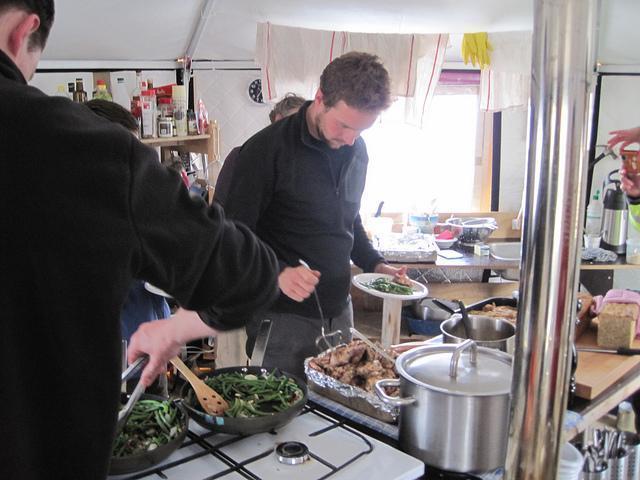How many yellow rubber gloves are in the picture?
Give a very brief answer. 2. How many people are in the picture?
Give a very brief answer. 2. How many ovens are in the picture?
Give a very brief answer. 1. 